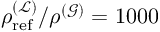<formula> <loc_0><loc_0><loc_500><loc_500>\rho _ { r e f } ^ { ( \mathcal { L } ) } / \rho ^ { ( \mathcal { G } ) } = 1 0 0 0</formula> 